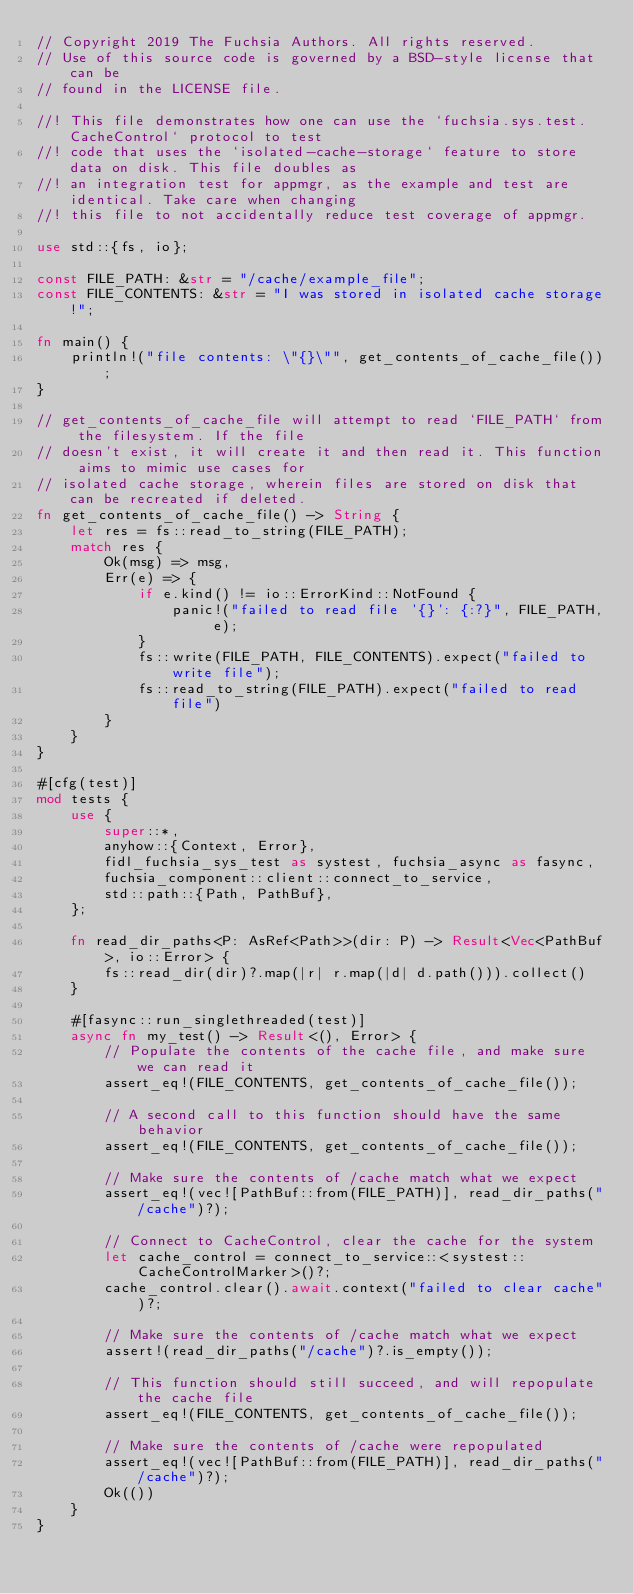<code> <loc_0><loc_0><loc_500><loc_500><_Rust_>// Copyright 2019 The Fuchsia Authors. All rights reserved.
// Use of this source code is governed by a BSD-style license that can be
// found in the LICENSE file.

//! This file demonstrates how one can use the `fuchsia.sys.test.CacheControl` protocol to test
//! code that uses the `isolated-cache-storage` feature to store data on disk. This file doubles as
//! an integration test for appmgr, as the example and test are identical. Take care when changing
//! this file to not accidentally reduce test coverage of appmgr.

use std::{fs, io};

const FILE_PATH: &str = "/cache/example_file";
const FILE_CONTENTS: &str = "I was stored in isolated cache storage!";

fn main() {
    println!("file contents: \"{}\"", get_contents_of_cache_file());
}

// get_contents_of_cache_file will attempt to read `FILE_PATH` from the filesystem. If the file
// doesn't exist, it will create it and then read it. This function aims to mimic use cases for
// isolated cache storage, wherein files are stored on disk that can be recreated if deleted.
fn get_contents_of_cache_file() -> String {
    let res = fs::read_to_string(FILE_PATH);
    match res {
        Ok(msg) => msg,
        Err(e) => {
            if e.kind() != io::ErrorKind::NotFound {
                panic!("failed to read file '{}': {:?}", FILE_PATH, e);
            }
            fs::write(FILE_PATH, FILE_CONTENTS).expect("failed to write file");
            fs::read_to_string(FILE_PATH).expect("failed to read file")
        }
    }
}

#[cfg(test)]
mod tests {
    use {
        super::*,
        anyhow::{Context, Error},
        fidl_fuchsia_sys_test as systest, fuchsia_async as fasync,
        fuchsia_component::client::connect_to_service,
        std::path::{Path, PathBuf},
    };

    fn read_dir_paths<P: AsRef<Path>>(dir: P) -> Result<Vec<PathBuf>, io::Error> {
        fs::read_dir(dir)?.map(|r| r.map(|d| d.path())).collect()
    }

    #[fasync::run_singlethreaded(test)]
    async fn my_test() -> Result<(), Error> {
        // Populate the contents of the cache file, and make sure we can read it
        assert_eq!(FILE_CONTENTS, get_contents_of_cache_file());

        // A second call to this function should have the same behavior
        assert_eq!(FILE_CONTENTS, get_contents_of_cache_file());

        // Make sure the contents of /cache match what we expect
        assert_eq!(vec![PathBuf::from(FILE_PATH)], read_dir_paths("/cache")?);

        // Connect to CacheControl, clear the cache for the system
        let cache_control = connect_to_service::<systest::CacheControlMarker>()?;
        cache_control.clear().await.context("failed to clear cache")?;

        // Make sure the contents of /cache match what we expect
        assert!(read_dir_paths("/cache")?.is_empty());

        // This function should still succeed, and will repopulate the cache file
        assert_eq!(FILE_CONTENTS, get_contents_of_cache_file());

        // Make sure the contents of /cache were repopulated
        assert_eq!(vec![PathBuf::from(FILE_PATH)], read_dir_paths("/cache")?);
        Ok(())
    }
}
</code> 